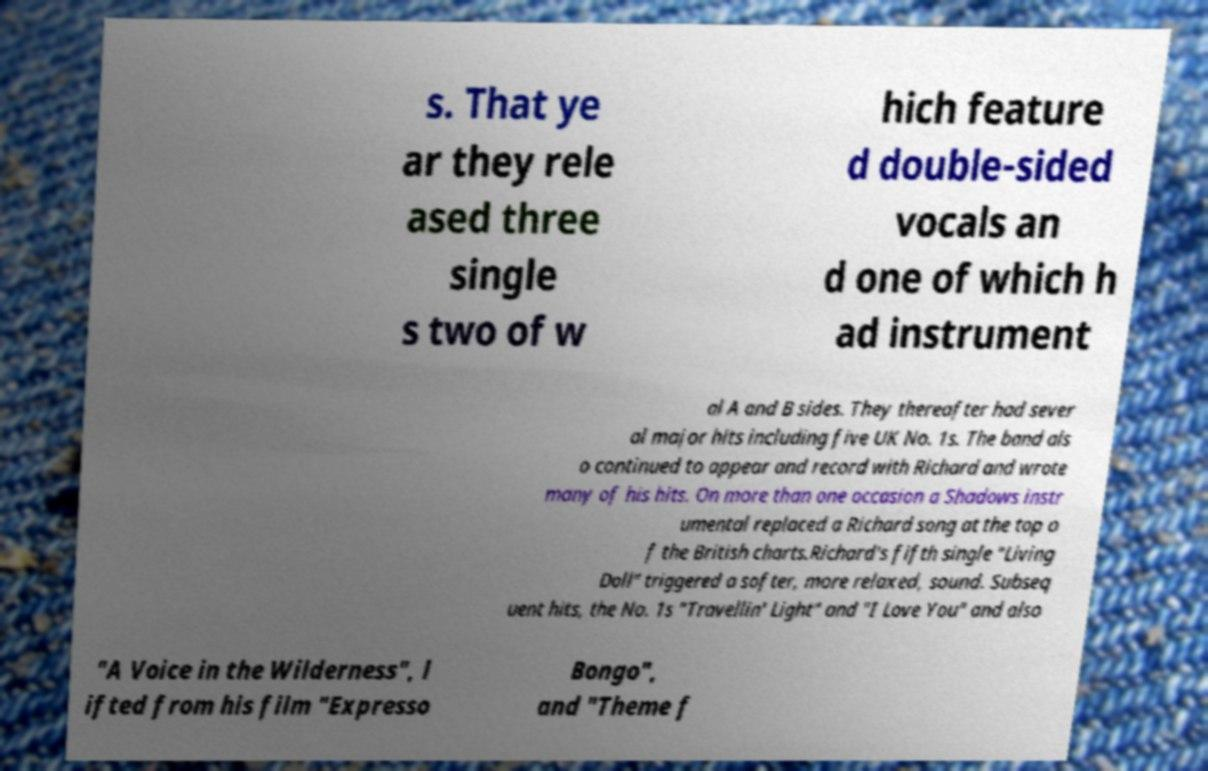I need the written content from this picture converted into text. Can you do that? s. That ye ar they rele ased three single s two of w hich feature d double-sided vocals an d one of which h ad instrument al A and B sides. They thereafter had sever al major hits including five UK No. 1s. The band als o continued to appear and record with Richard and wrote many of his hits. On more than one occasion a Shadows instr umental replaced a Richard song at the top o f the British charts.Richard's fifth single "Living Doll" triggered a softer, more relaxed, sound. Subseq uent hits, the No. 1s "Travellin' Light" and "I Love You" and also "A Voice in the Wilderness", l ifted from his film "Expresso Bongo", and "Theme f 